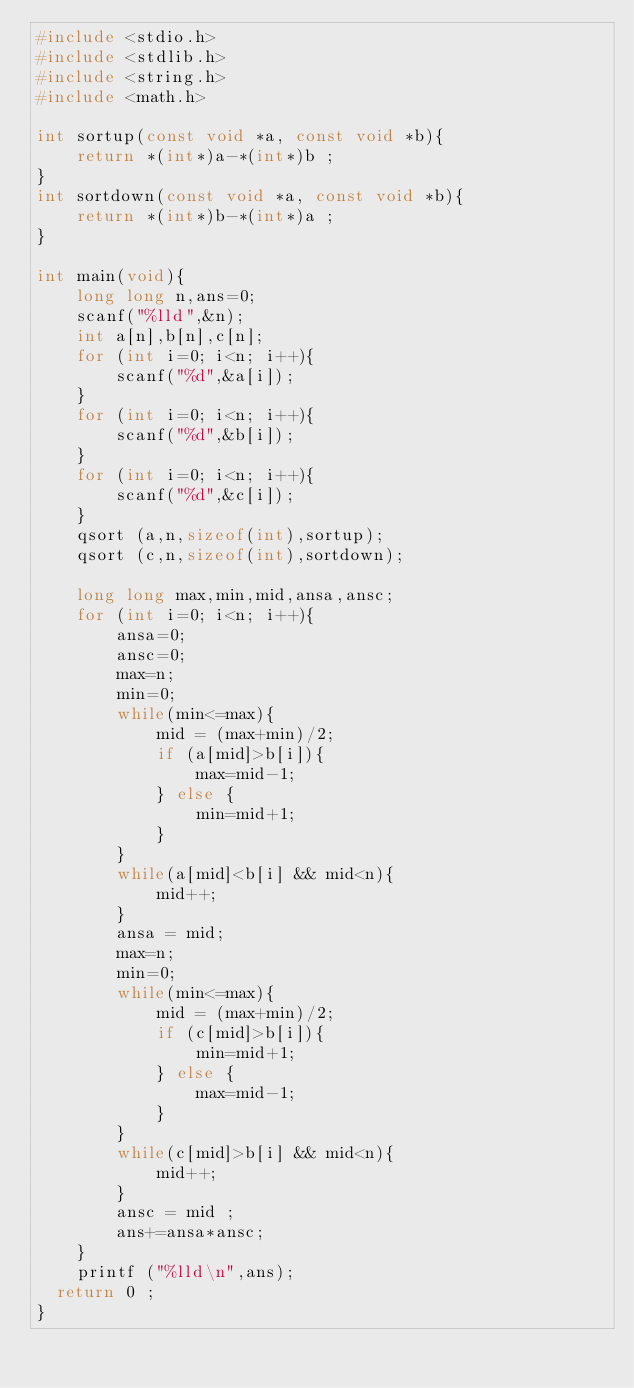Convert code to text. <code><loc_0><loc_0><loc_500><loc_500><_C_>#include <stdio.h>
#include <stdlib.h>
#include <string.h>
#include <math.h>

int sortup(const void *a, const void *b){
    return *(int*)a-*(int*)b ;
}
int sortdown(const void *a, const void *b){
    return *(int*)b-*(int*)a ;
}

int main(void){
    long long n,ans=0;
    scanf("%lld",&n);
    int a[n],b[n],c[n];
    for (int i=0; i<n; i++){
        scanf("%d",&a[i]);
    }
    for (int i=0; i<n; i++){
        scanf("%d",&b[i]);
    }
    for (int i=0; i<n; i++){
        scanf("%d",&c[i]);
    }
    qsort (a,n,sizeof(int),sortup);
    qsort (c,n,sizeof(int),sortdown);
    
    long long max,min,mid,ansa,ansc;
    for (int i=0; i<n; i++){
        ansa=0;
        ansc=0;
        max=n;
        min=0;
        while(min<=max){
            mid = (max+min)/2;
            if (a[mid]>b[i]){
                max=mid-1;
            } else {
                min=mid+1;
            }
        }
        while(a[mid]<b[i] && mid<n){
            mid++;
        }
        ansa = mid;
        max=n;
        min=0;
        while(min<=max){
            mid = (max+min)/2;
            if (c[mid]>b[i]){
                min=mid+1;
            } else {
                max=mid-1;
            }
        }
        while(c[mid]>b[i] && mid<n){
            mid++;
        }
        ansc = mid ;
        ans+=ansa*ansc;
    }
    printf ("%lld\n",ans);
	return 0 ;
}</code> 